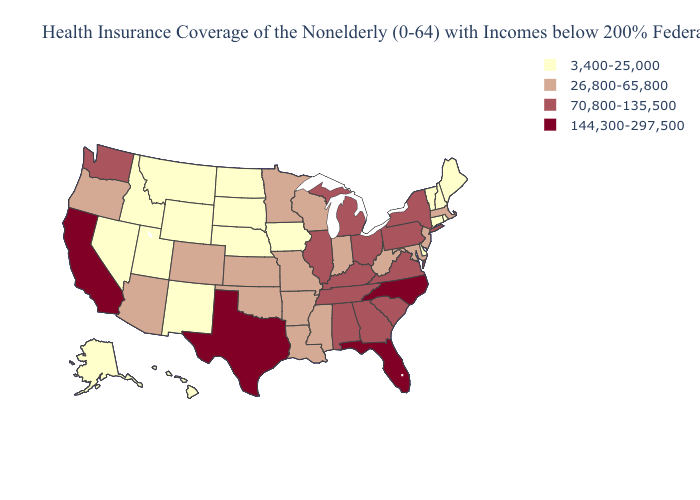Does Michigan have the highest value in the USA?
Quick response, please. No. Name the states that have a value in the range 144,300-297,500?
Keep it brief. California, Florida, North Carolina, Texas. Does Virginia have the same value as Delaware?
Quick response, please. No. Name the states that have a value in the range 144,300-297,500?
Give a very brief answer. California, Florida, North Carolina, Texas. Does North Carolina have the highest value in the USA?
Quick response, please. Yes. Which states have the highest value in the USA?
Concise answer only. California, Florida, North Carolina, Texas. Among the states that border Indiana , which have the lowest value?
Answer briefly. Illinois, Kentucky, Michigan, Ohio. Name the states that have a value in the range 70,800-135,500?
Short answer required. Alabama, Georgia, Illinois, Kentucky, Michigan, New York, Ohio, Pennsylvania, South Carolina, Tennessee, Virginia, Washington. Name the states that have a value in the range 3,400-25,000?
Answer briefly. Alaska, Connecticut, Delaware, Hawaii, Idaho, Iowa, Maine, Montana, Nebraska, Nevada, New Hampshire, New Mexico, North Dakota, Rhode Island, South Dakota, Utah, Vermont, Wyoming. What is the lowest value in states that border Wyoming?
Write a very short answer. 3,400-25,000. Which states have the lowest value in the MidWest?
Answer briefly. Iowa, Nebraska, North Dakota, South Dakota. Does Missouri have the highest value in the MidWest?
Concise answer only. No. What is the value of Nebraska?
Write a very short answer. 3,400-25,000. What is the highest value in the MidWest ?
Quick response, please. 70,800-135,500. 